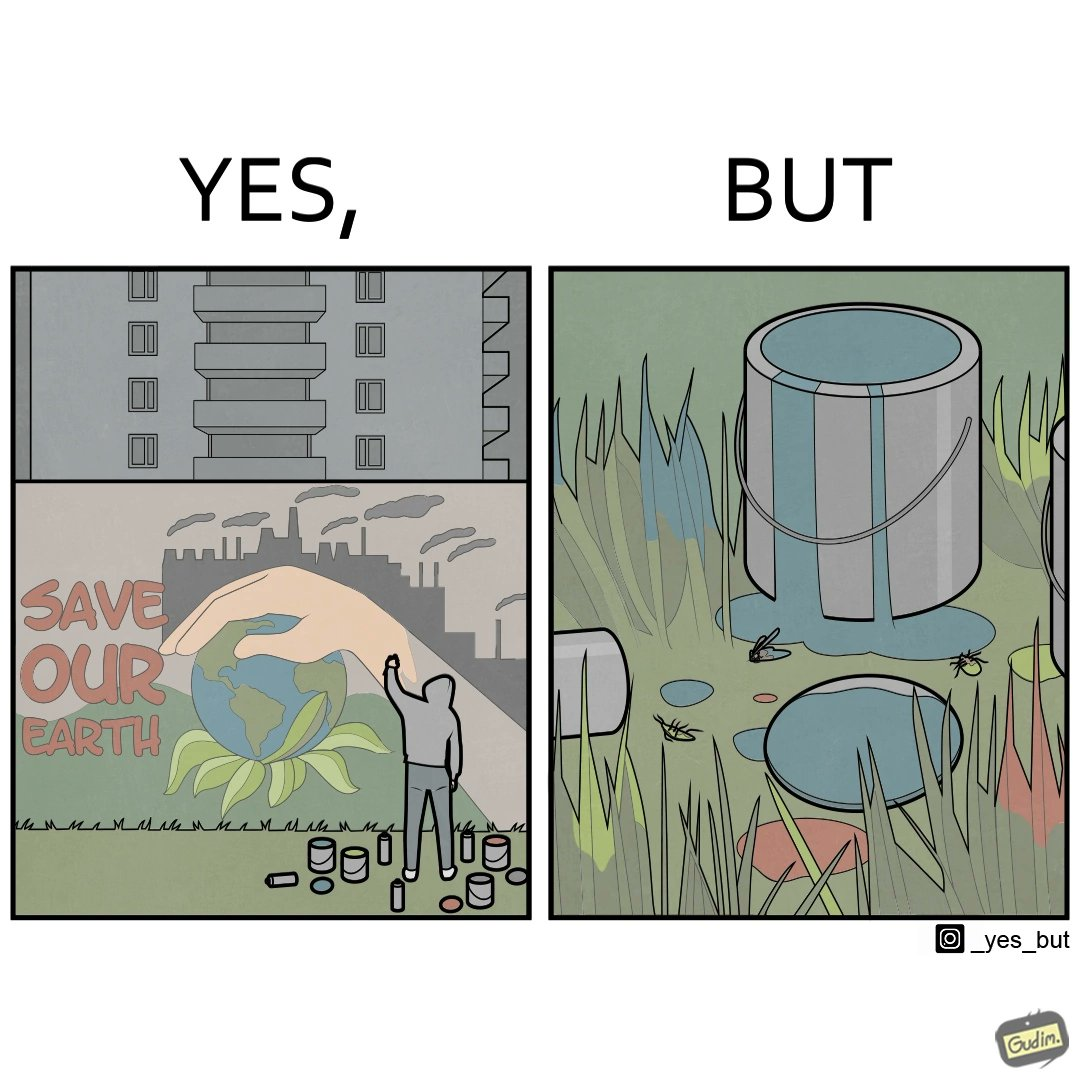Describe what you see in the left and right parts of this image. In the left part of the image: A man drawing a graffiti themed "save Our earth". In the right part of the image: A can of paint, overflowing onto the grass. The paint seems to be harmful for insects. 